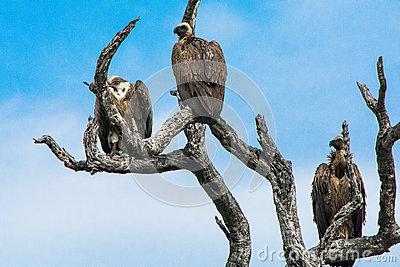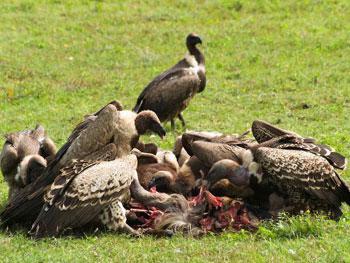The first image is the image on the left, the second image is the image on the right. For the images shown, is this caption "There are two vultures in the image pair" true? Answer yes or no. No. The first image is the image on the left, the second image is the image on the right. Analyze the images presented: Is the assertion "There is exactly one vulture and one eagle." valid? Answer yes or no. No. 